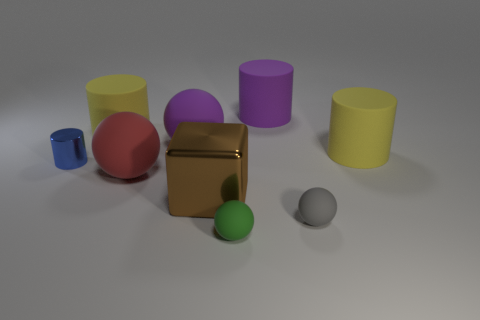Add 1 large spheres. How many objects exist? 10 Subtract all green cylinders. Subtract all blue balls. How many cylinders are left? 4 Subtract all balls. How many objects are left? 5 Add 6 brown metallic objects. How many brown metallic objects exist? 7 Subtract 0 gray cubes. How many objects are left? 9 Subtract all brown things. Subtract all big purple spheres. How many objects are left? 7 Add 8 large purple rubber things. How many large purple rubber things are left? 10 